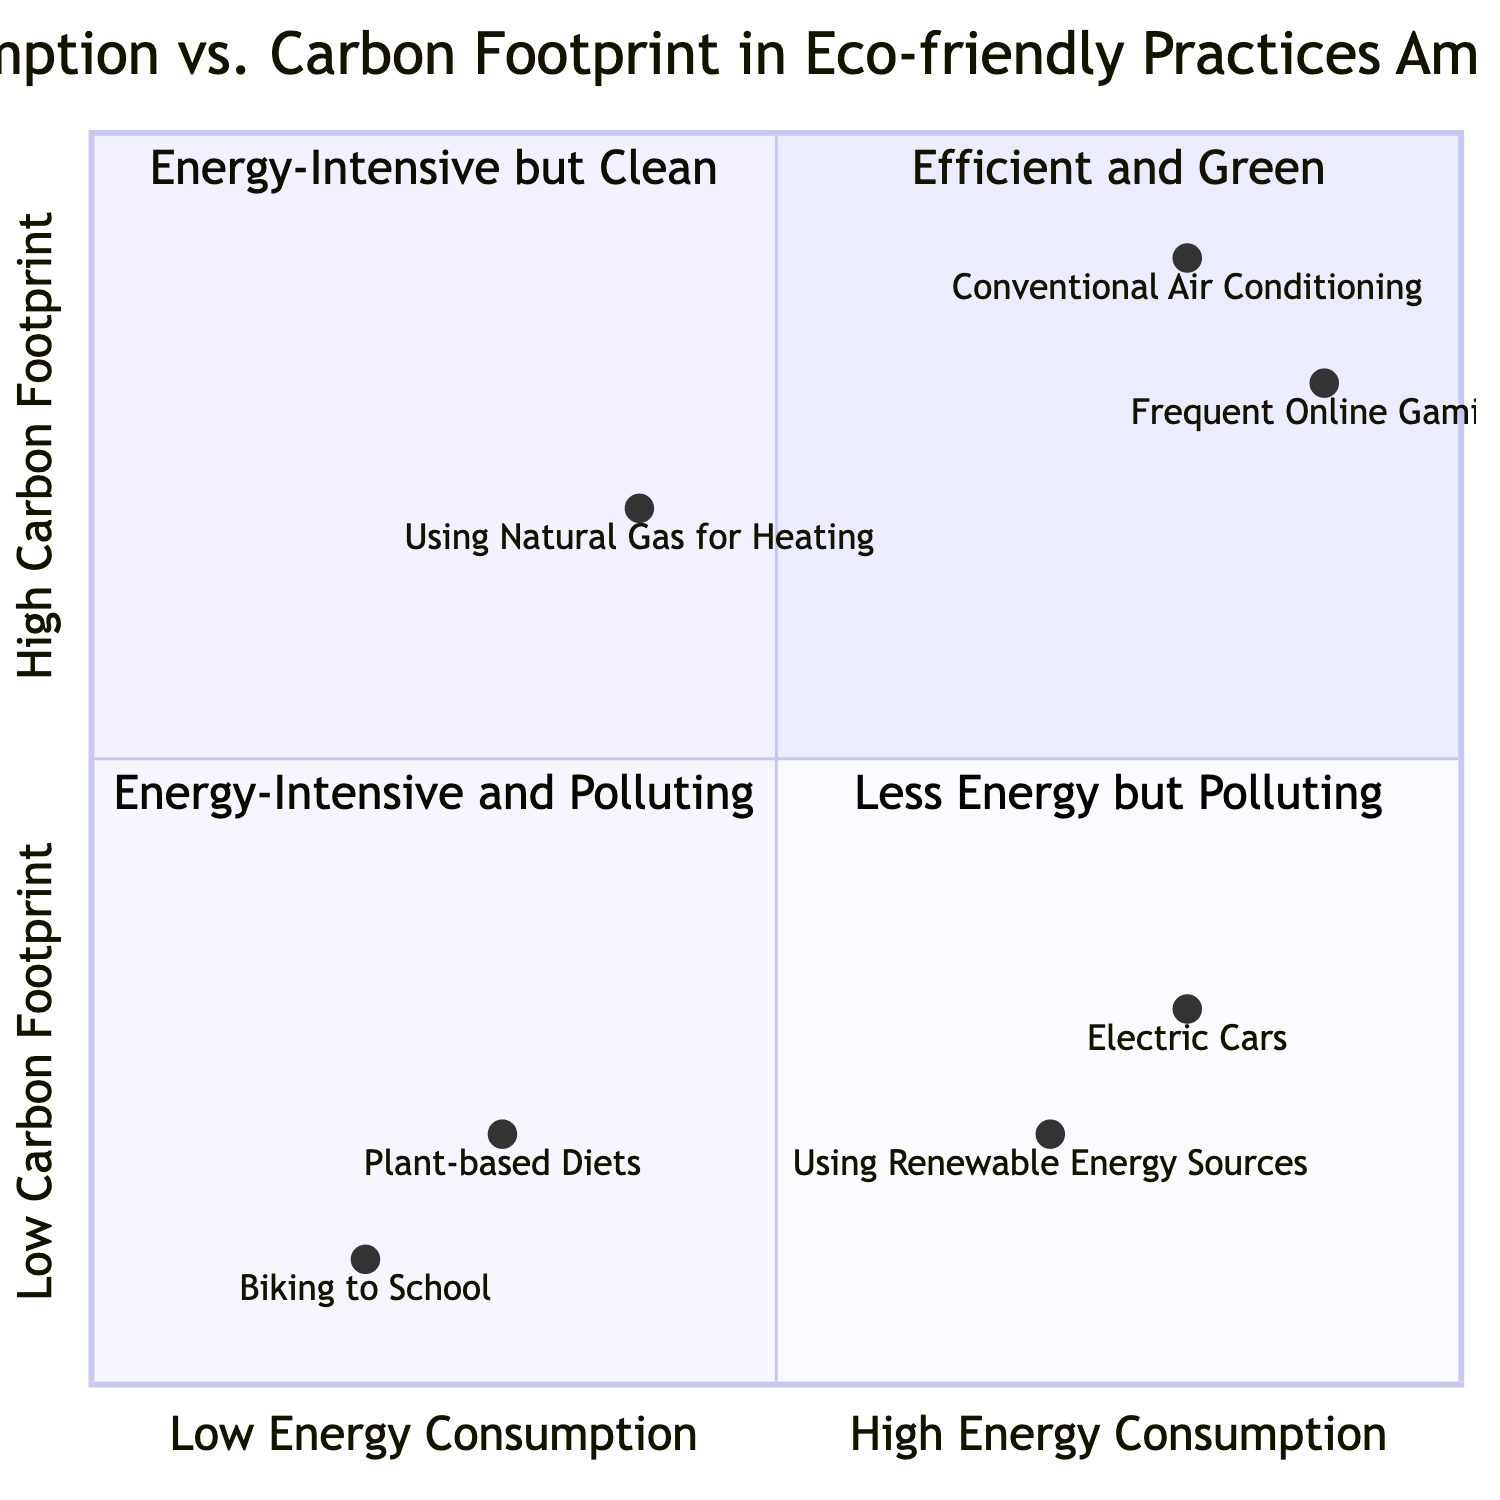What is the practice located in the "Efficient and Green" quadrant? In the "Efficient and Green" quadrant, the practices listed are those that have both low energy consumption and low carbon footprints. From the data provided, "Biking to School" and "Plant-based Diets" are found in this quadrant.
Answer: Biking to School How many practices are in the "Energy-Intensive and Polluting" quadrant? The "Energy-Intensive and Polluting" quadrant contains practices characterized by high energy consumption and high carbon footprints. Based on the data, there are two practices: "Frequent Online Gaming" and "Conventional Air Conditioning". Therefore, the total count is 2.
Answer: 2 Which practice uses renewable energy sources but has high energy consumption? The practice that uses renewable energy sources but is located in the high energy consumption area is "Using Renewable Energy Sources". It falls into the "Energy-Intensive but Clean" quadrant since it requires energy for production but has a low operational carbon footprint.
Answer: Using Renewable Energy Sources What is the carbon footprint of "Using Natural Gas for Heating"? The carbon footprint for "Using Natural Gas for Heating" is categorized as high. It has a high carbon footprint value according to the placement in the "Less Energy but Polluting" quadrant, specifically indicated by a y-axis value around 0.7.
Answer: High Compare the energy consumption of "Electric Cars" and "Biking to School". "Electric Cars" show a higher energy consumption compared to "Biking to School". "Electric Cars" are located at x=0.8 on the x-axis indicating high energy consumption, whereas "Biking to School" is at x=0.2, indicating low energy consumption. Thus, electric cars consume more energy.
Answer: Electric Cars What is the practice found in the lowest energy and carbon footprint quadrant? In the lowest energy and carbon footprint quadrant, which is labeled "Efficient and Green," the practices listed are "Biking to School" and "Plant-based Diets". The key practice here is "Biking to School," as it has the lowest values on both axes.
Answer: Biking to School Identify two practices with high energy consumption. The two practices with high energy consumption are "Electric Cars" and "Frequent Online Gaming", both located to the right side of the x-axis (x > 0.5).
Answer: Electric Cars and Frequent Online Gaming Which practice has the lowest carbon footprint among those listed? The practice with the lowest carbon footprint is "Biking to School", with a y-axis value of 0.1, making it the lowest carbon footprint practice according to the diagram's configuration.
Answer: Biking to School 